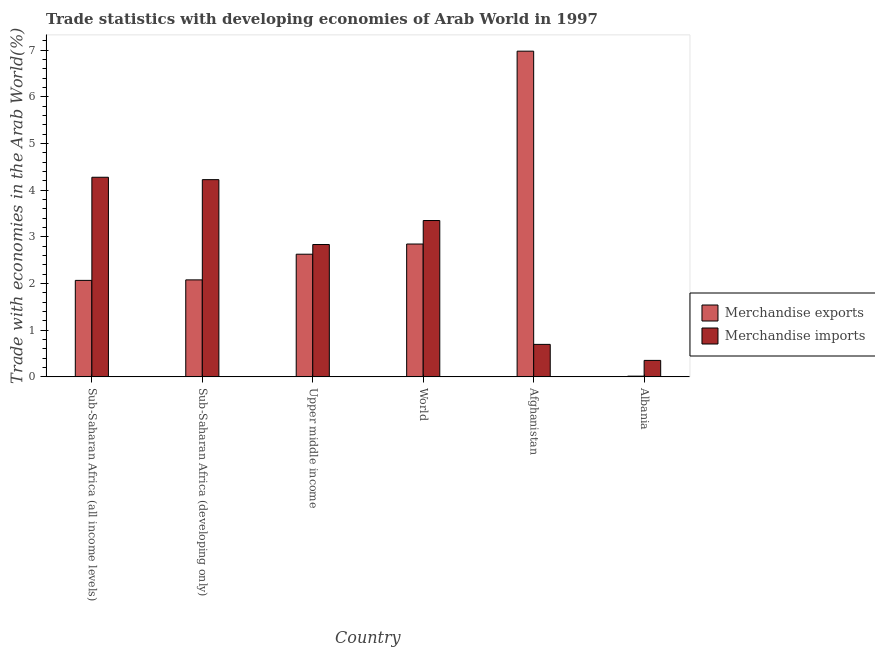How many groups of bars are there?
Provide a short and direct response. 6. Are the number of bars per tick equal to the number of legend labels?
Offer a very short reply. Yes. Are the number of bars on each tick of the X-axis equal?
Offer a terse response. Yes. What is the label of the 2nd group of bars from the left?
Your answer should be very brief. Sub-Saharan Africa (developing only). What is the merchandise exports in Sub-Saharan Africa (all income levels)?
Make the answer very short. 2.07. Across all countries, what is the maximum merchandise imports?
Ensure brevity in your answer.  4.28. Across all countries, what is the minimum merchandise exports?
Make the answer very short. 0.02. In which country was the merchandise imports maximum?
Give a very brief answer. Sub-Saharan Africa (all income levels). In which country was the merchandise exports minimum?
Your answer should be very brief. Albania. What is the total merchandise imports in the graph?
Offer a very short reply. 15.73. What is the difference between the merchandise exports in Afghanistan and that in Sub-Saharan Africa (developing only)?
Offer a very short reply. 4.9. What is the difference between the merchandise exports in Sub-Saharan Africa (developing only) and the merchandise imports in Albania?
Ensure brevity in your answer.  1.72. What is the average merchandise exports per country?
Provide a succinct answer. 2.77. What is the difference between the merchandise imports and merchandise exports in Upper middle income?
Make the answer very short. 0.21. In how many countries, is the merchandise exports greater than 1.6 %?
Provide a short and direct response. 5. What is the ratio of the merchandise exports in Sub-Saharan Africa (developing only) to that in World?
Offer a very short reply. 0.73. Is the merchandise exports in Sub-Saharan Africa (all income levels) less than that in World?
Offer a very short reply. Yes. Is the difference between the merchandise imports in Sub-Saharan Africa (developing only) and Upper middle income greater than the difference between the merchandise exports in Sub-Saharan Africa (developing only) and Upper middle income?
Your response must be concise. Yes. What is the difference between the highest and the second highest merchandise exports?
Offer a terse response. 4.13. What is the difference between the highest and the lowest merchandise exports?
Provide a succinct answer. 6.96. In how many countries, is the merchandise exports greater than the average merchandise exports taken over all countries?
Your answer should be very brief. 2. How many bars are there?
Make the answer very short. 12. What is the difference between two consecutive major ticks on the Y-axis?
Your response must be concise. 1. Are the values on the major ticks of Y-axis written in scientific E-notation?
Provide a succinct answer. No. Does the graph contain grids?
Your answer should be very brief. No. How many legend labels are there?
Provide a succinct answer. 2. What is the title of the graph?
Offer a very short reply. Trade statistics with developing economies of Arab World in 1997. Does "Mobile cellular" appear as one of the legend labels in the graph?
Keep it short and to the point. No. What is the label or title of the X-axis?
Offer a very short reply. Country. What is the label or title of the Y-axis?
Ensure brevity in your answer.  Trade with economies in the Arab World(%). What is the Trade with economies in the Arab World(%) of Merchandise exports in Sub-Saharan Africa (all income levels)?
Your response must be concise. 2.07. What is the Trade with economies in the Arab World(%) in Merchandise imports in Sub-Saharan Africa (all income levels)?
Offer a terse response. 4.28. What is the Trade with economies in the Arab World(%) in Merchandise exports in Sub-Saharan Africa (developing only)?
Provide a short and direct response. 2.08. What is the Trade with economies in the Arab World(%) in Merchandise imports in Sub-Saharan Africa (developing only)?
Provide a short and direct response. 4.22. What is the Trade with economies in the Arab World(%) in Merchandise exports in Upper middle income?
Give a very brief answer. 2.63. What is the Trade with economies in the Arab World(%) in Merchandise imports in Upper middle income?
Provide a succinct answer. 2.83. What is the Trade with economies in the Arab World(%) of Merchandise exports in World?
Offer a terse response. 2.85. What is the Trade with economies in the Arab World(%) in Merchandise imports in World?
Your response must be concise. 3.35. What is the Trade with economies in the Arab World(%) of Merchandise exports in Afghanistan?
Your response must be concise. 6.98. What is the Trade with economies in the Arab World(%) in Merchandise imports in Afghanistan?
Provide a succinct answer. 0.7. What is the Trade with economies in the Arab World(%) in Merchandise exports in Albania?
Offer a terse response. 0.02. What is the Trade with economies in the Arab World(%) of Merchandise imports in Albania?
Your answer should be very brief. 0.35. Across all countries, what is the maximum Trade with economies in the Arab World(%) of Merchandise exports?
Keep it short and to the point. 6.98. Across all countries, what is the maximum Trade with economies in the Arab World(%) of Merchandise imports?
Give a very brief answer. 4.28. Across all countries, what is the minimum Trade with economies in the Arab World(%) in Merchandise exports?
Offer a terse response. 0.02. Across all countries, what is the minimum Trade with economies in the Arab World(%) in Merchandise imports?
Provide a short and direct response. 0.35. What is the total Trade with economies in the Arab World(%) in Merchandise exports in the graph?
Make the answer very short. 16.61. What is the total Trade with economies in the Arab World(%) in Merchandise imports in the graph?
Keep it short and to the point. 15.73. What is the difference between the Trade with economies in the Arab World(%) in Merchandise exports in Sub-Saharan Africa (all income levels) and that in Sub-Saharan Africa (developing only)?
Give a very brief answer. -0.01. What is the difference between the Trade with economies in the Arab World(%) of Merchandise imports in Sub-Saharan Africa (all income levels) and that in Sub-Saharan Africa (developing only)?
Your answer should be compact. 0.05. What is the difference between the Trade with economies in the Arab World(%) in Merchandise exports in Sub-Saharan Africa (all income levels) and that in Upper middle income?
Provide a short and direct response. -0.56. What is the difference between the Trade with economies in the Arab World(%) of Merchandise imports in Sub-Saharan Africa (all income levels) and that in Upper middle income?
Keep it short and to the point. 1.44. What is the difference between the Trade with economies in the Arab World(%) of Merchandise exports in Sub-Saharan Africa (all income levels) and that in World?
Your answer should be compact. -0.78. What is the difference between the Trade with economies in the Arab World(%) in Merchandise imports in Sub-Saharan Africa (all income levels) and that in World?
Your answer should be compact. 0.93. What is the difference between the Trade with economies in the Arab World(%) in Merchandise exports in Sub-Saharan Africa (all income levels) and that in Afghanistan?
Your answer should be very brief. -4.91. What is the difference between the Trade with economies in the Arab World(%) in Merchandise imports in Sub-Saharan Africa (all income levels) and that in Afghanistan?
Offer a terse response. 3.58. What is the difference between the Trade with economies in the Arab World(%) of Merchandise exports in Sub-Saharan Africa (all income levels) and that in Albania?
Your response must be concise. 2.05. What is the difference between the Trade with economies in the Arab World(%) in Merchandise imports in Sub-Saharan Africa (all income levels) and that in Albania?
Offer a terse response. 3.92. What is the difference between the Trade with economies in the Arab World(%) in Merchandise exports in Sub-Saharan Africa (developing only) and that in Upper middle income?
Your answer should be very brief. -0.55. What is the difference between the Trade with economies in the Arab World(%) in Merchandise imports in Sub-Saharan Africa (developing only) and that in Upper middle income?
Your answer should be very brief. 1.39. What is the difference between the Trade with economies in the Arab World(%) in Merchandise exports in Sub-Saharan Africa (developing only) and that in World?
Make the answer very short. -0.77. What is the difference between the Trade with economies in the Arab World(%) in Merchandise imports in Sub-Saharan Africa (developing only) and that in World?
Provide a short and direct response. 0.88. What is the difference between the Trade with economies in the Arab World(%) in Merchandise exports in Sub-Saharan Africa (developing only) and that in Afghanistan?
Your answer should be compact. -4.9. What is the difference between the Trade with economies in the Arab World(%) of Merchandise imports in Sub-Saharan Africa (developing only) and that in Afghanistan?
Offer a very short reply. 3.53. What is the difference between the Trade with economies in the Arab World(%) of Merchandise exports in Sub-Saharan Africa (developing only) and that in Albania?
Make the answer very short. 2.06. What is the difference between the Trade with economies in the Arab World(%) in Merchandise imports in Sub-Saharan Africa (developing only) and that in Albania?
Provide a succinct answer. 3.87. What is the difference between the Trade with economies in the Arab World(%) of Merchandise exports in Upper middle income and that in World?
Your answer should be compact. -0.22. What is the difference between the Trade with economies in the Arab World(%) in Merchandise imports in Upper middle income and that in World?
Offer a terse response. -0.51. What is the difference between the Trade with economies in the Arab World(%) in Merchandise exports in Upper middle income and that in Afghanistan?
Keep it short and to the point. -4.35. What is the difference between the Trade with economies in the Arab World(%) of Merchandise imports in Upper middle income and that in Afghanistan?
Provide a succinct answer. 2.14. What is the difference between the Trade with economies in the Arab World(%) in Merchandise exports in Upper middle income and that in Albania?
Provide a succinct answer. 2.61. What is the difference between the Trade with economies in the Arab World(%) in Merchandise imports in Upper middle income and that in Albania?
Offer a terse response. 2.48. What is the difference between the Trade with economies in the Arab World(%) in Merchandise exports in World and that in Afghanistan?
Give a very brief answer. -4.13. What is the difference between the Trade with economies in the Arab World(%) in Merchandise imports in World and that in Afghanistan?
Make the answer very short. 2.65. What is the difference between the Trade with economies in the Arab World(%) in Merchandise exports in World and that in Albania?
Offer a very short reply. 2.83. What is the difference between the Trade with economies in the Arab World(%) in Merchandise imports in World and that in Albania?
Make the answer very short. 3. What is the difference between the Trade with economies in the Arab World(%) of Merchandise exports in Afghanistan and that in Albania?
Your answer should be compact. 6.96. What is the difference between the Trade with economies in the Arab World(%) of Merchandise imports in Afghanistan and that in Albania?
Provide a succinct answer. 0.34. What is the difference between the Trade with economies in the Arab World(%) of Merchandise exports in Sub-Saharan Africa (all income levels) and the Trade with economies in the Arab World(%) of Merchandise imports in Sub-Saharan Africa (developing only)?
Keep it short and to the point. -2.16. What is the difference between the Trade with economies in the Arab World(%) in Merchandise exports in Sub-Saharan Africa (all income levels) and the Trade with economies in the Arab World(%) in Merchandise imports in Upper middle income?
Offer a very short reply. -0.77. What is the difference between the Trade with economies in the Arab World(%) of Merchandise exports in Sub-Saharan Africa (all income levels) and the Trade with economies in the Arab World(%) of Merchandise imports in World?
Make the answer very short. -1.28. What is the difference between the Trade with economies in the Arab World(%) of Merchandise exports in Sub-Saharan Africa (all income levels) and the Trade with economies in the Arab World(%) of Merchandise imports in Afghanistan?
Give a very brief answer. 1.37. What is the difference between the Trade with economies in the Arab World(%) of Merchandise exports in Sub-Saharan Africa (all income levels) and the Trade with economies in the Arab World(%) of Merchandise imports in Albania?
Provide a short and direct response. 1.71. What is the difference between the Trade with economies in the Arab World(%) in Merchandise exports in Sub-Saharan Africa (developing only) and the Trade with economies in the Arab World(%) in Merchandise imports in Upper middle income?
Keep it short and to the point. -0.76. What is the difference between the Trade with economies in the Arab World(%) of Merchandise exports in Sub-Saharan Africa (developing only) and the Trade with economies in the Arab World(%) of Merchandise imports in World?
Offer a very short reply. -1.27. What is the difference between the Trade with economies in the Arab World(%) of Merchandise exports in Sub-Saharan Africa (developing only) and the Trade with economies in the Arab World(%) of Merchandise imports in Afghanistan?
Ensure brevity in your answer.  1.38. What is the difference between the Trade with economies in the Arab World(%) in Merchandise exports in Sub-Saharan Africa (developing only) and the Trade with economies in the Arab World(%) in Merchandise imports in Albania?
Ensure brevity in your answer.  1.72. What is the difference between the Trade with economies in the Arab World(%) of Merchandise exports in Upper middle income and the Trade with economies in the Arab World(%) of Merchandise imports in World?
Your answer should be very brief. -0.72. What is the difference between the Trade with economies in the Arab World(%) in Merchandise exports in Upper middle income and the Trade with economies in the Arab World(%) in Merchandise imports in Afghanistan?
Keep it short and to the point. 1.93. What is the difference between the Trade with economies in the Arab World(%) in Merchandise exports in Upper middle income and the Trade with economies in the Arab World(%) in Merchandise imports in Albania?
Provide a short and direct response. 2.27. What is the difference between the Trade with economies in the Arab World(%) in Merchandise exports in World and the Trade with economies in the Arab World(%) in Merchandise imports in Afghanistan?
Offer a very short reply. 2.15. What is the difference between the Trade with economies in the Arab World(%) of Merchandise exports in World and the Trade with economies in the Arab World(%) of Merchandise imports in Albania?
Ensure brevity in your answer.  2.49. What is the difference between the Trade with economies in the Arab World(%) of Merchandise exports in Afghanistan and the Trade with economies in the Arab World(%) of Merchandise imports in Albania?
Your answer should be very brief. 6.62. What is the average Trade with economies in the Arab World(%) in Merchandise exports per country?
Your answer should be very brief. 2.77. What is the average Trade with economies in the Arab World(%) in Merchandise imports per country?
Your response must be concise. 2.62. What is the difference between the Trade with economies in the Arab World(%) in Merchandise exports and Trade with economies in the Arab World(%) in Merchandise imports in Sub-Saharan Africa (all income levels)?
Provide a short and direct response. -2.21. What is the difference between the Trade with economies in the Arab World(%) of Merchandise exports and Trade with economies in the Arab World(%) of Merchandise imports in Sub-Saharan Africa (developing only)?
Your answer should be compact. -2.15. What is the difference between the Trade with economies in the Arab World(%) in Merchandise exports and Trade with economies in the Arab World(%) in Merchandise imports in Upper middle income?
Make the answer very short. -0.21. What is the difference between the Trade with economies in the Arab World(%) in Merchandise exports and Trade with economies in the Arab World(%) in Merchandise imports in World?
Keep it short and to the point. -0.5. What is the difference between the Trade with economies in the Arab World(%) in Merchandise exports and Trade with economies in the Arab World(%) in Merchandise imports in Afghanistan?
Give a very brief answer. 6.28. What is the difference between the Trade with economies in the Arab World(%) in Merchandise exports and Trade with economies in the Arab World(%) in Merchandise imports in Albania?
Make the answer very short. -0.34. What is the ratio of the Trade with economies in the Arab World(%) of Merchandise exports in Sub-Saharan Africa (all income levels) to that in Sub-Saharan Africa (developing only)?
Your answer should be compact. 0.99. What is the ratio of the Trade with economies in the Arab World(%) in Merchandise imports in Sub-Saharan Africa (all income levels) to that in Sub-Saharan Africa (developing only)?
Provide a short and direct response. 1.01. What is the ratio of the Trade with economies in the Arab World(%) of Merchandise exports in Sub-Saharan Africa (all income levels) to that in Upper middle income?
Ensure brevity in your answer.  0.79. What is the ratio of the Trade with economies in the Arab World(%) in Merchandise imports in Sub-Saharan Africa (all income levels) to that in Upper middle income?
Offer a very short reply. 1.51. What is the ratio of the Trade with economies in the Arab World(%) of Merchandise exports in Sub-Saharan Africa (all income levels) to that in World?
Make the answer very short. 0.73. What is the ratio of the Trade with economies in the Arab World(%) in Merchandise imports in Sub-Saharan Africa (all income levels) to that in World?
Keep it short and to the point. 1.28. What is the ratio of the Trade with economies in the Arab World(%) in Merchandise exports in Sub-Saharan Africa (all income levels) to that in Afghanistan?
Your response must be concise. 0.3. What is the ratio of the Trade with economies in the Arab World(%) in Merchandise imports in Sub-Saharan Africa (all income levels) to that in Afghanistan?
Make the answer very short. 6.14. What is the ratio of the Trade with economies in the Arab World(%) of Merchandise exports in Sub-Saharan Africa (all income levels) to that in Albania?
Your answer should be compact. 133.62. What is the ratio of the Trade with economies in the Arab World(%) in Merchandise imports in Sub-Saharan Africa (all income levels) to that in Albania?
Your answer should be compact. 12.12. What is the ratio of the Trade with economies in the Arab World(%) in Merchandise exports in Sub-Saharan Africa (developing only) to that in Upper middle income?
Provide a short and direct response. 0.79. What is the ratio of the Trade with economies in the Arab World(%) in Merchandise imports in Sub-Saharan Africa (developing only) to that in Upper middle income?
Provide a short and direct response. 1.49. What is the ratio of the Trade with economies in the Arab World(%) in Merchandise exports in Sub-Saharan Africa (developing only) to that in World?
Make the answer very short. 0.73. What is the ratio of the Trade with economies in the Arab World(%) of Merchandise imports in Sub-Saharan Africa (developing only) to that in World?
Your answer should be compact. 1.26. What is the ratio of the Trade with economies in the Arab World(%) of Merchandise exports in Sub-Saharan Africa (developing only) to that in Afghanistan?
Ensure brevity in your answer.  0.3. What is the ratio of the Trade with economies in the Arab World(%) of Merchandise imports in Sub-Saharan Africa (developing only) to that in Afghanistan?
Give a very brief answer. 6.07. What is the ratio of the Trade with economies in the Arab World(%) of Merchandise exports in Sub-Saharan Africa (developing only) to that in Albania?
Give a very brief answer. 134.31. What is the ratio of the Trade with economies in the Arab World(%) in Merchandise imports in Sub-Saharan Africa (developing only) to that in Albania?
Provide a succinct answer. 11.97. What is the ratio of the Trade with economies in the Arab World(%) in Merchandise exports in Upper middle income to that in World?
Make the answer very short. 0.92. What is the ratio of the Trade with economies in the Arab World(%) in Merchandise imports in Upper middle income to that in World?
Your answer should be compact. 0.85. What is the ratio of the Trade with economies in the Arab World(%) in Merchandise exports in Upper middle income to that in Afghanistan?
Make the answer very short. 0.38. What is the ratio of the Trade with economies in the Arab World(%) in Merchandise imports in Upper middle income to that in Afghanistan?
Keep it short and to the point. 4.07. What is the ratio of the Trade with economies in the Arab World(%) in Merchandise exports in Upper middle income to that in Albania?
Your response must be concise. 169.85. What is the ratio of the Trade with economies in the Arab World(%) of Merchandise imports in Upper middle income to that in Albania?
Give a very brief answer. 8.03. What is the ratio of the Trade with economies in the Arab World(%) in Merchandise exports in World to that in Afghanistan?
Your response must be concise. 0.41. What is the ratio of the Trade with economies in the Arab World(%) in Merchandise imports in World to that in Afghanistan?
Make the answer very short. 4.81. What is the ratio of the Trade with economies in the Arab World(%) of Merchandise exports in World to that in Albania?
Your answer should be compact. 183.96. What is the ratio of the Trade with economies in the Arab World(%) in Merchandise imports in World to that in Albania?
Your response must be concise. 9.49. What is the ratio of the Trade with economies in the Arab World(%) of Merchandise exports in Afghanistan to that in Albania?
Ensure brevity in your answer.  451.03. What is the ratio of the Trade with economies in the Arab World(%) in Merchandise imports in Afghanistan to that in Albania?
Offer a terse response. 1.97. What is the difference between the highest and the second highest Trade with economies in the Arab World(%) in Merchandise exports?
Your answer should be very brief. 4.13. What is the difference between the highest and the second highest Trade with economies in the Arab World(%) of Merchandise imports?
Provide a succinct answer. 0.05. What is the difference between the highest and the lowest Trade with economies in the Arab World(%) in Merchandise exports?
Your answer should be very brief. 6.96. What is the difference between the highest and the lowest Trade with economies in the Arab World(%) of Merchandise imports?
Provide a succinct answer. 3.92. 